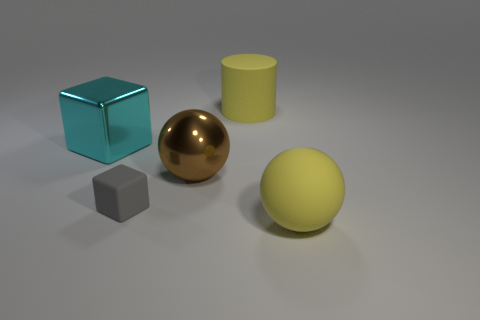Add 2 big things. How many objects exist? 7 Subtract all blocks. How many objects are left? 3 Add 5 gray matte cubes. How many gray matte cubes exist? 6 Subtract 1 yellow cylinders. How many objects are left? 4 Subtract all gray blocks. Subtract all shiny objects. How many objects are left? 2 Add 3 big cylinders. How many big cylinders are left? 4 